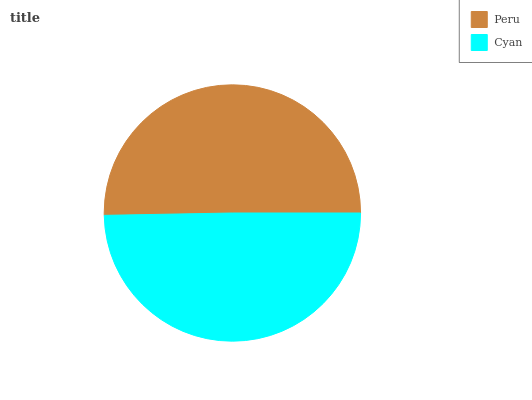Is Cyan the minimum?
Answer yes or no. Yes. Is Peru the maximum?
Answer yes or no. Yes. Is Cyan the maximum?
Answer yes or no. No. Is Peru greater than Cyan?
Answer yes or no. Yes. Is Cyan less than Peru?
Answer yes or no. Yes. Is Cyan greater than Peru?
Answer yes or no. No. Is Peru less than Cyan?
Answer yes or no. No. Is Peru the high median?
Answer yes or no. Yes. Is Cyan the low median?
Answer yes or no. Yes. Is Cyan the high median?
Answer yes or no. No. Is Peru the low median?
Answer yes or no. No. 